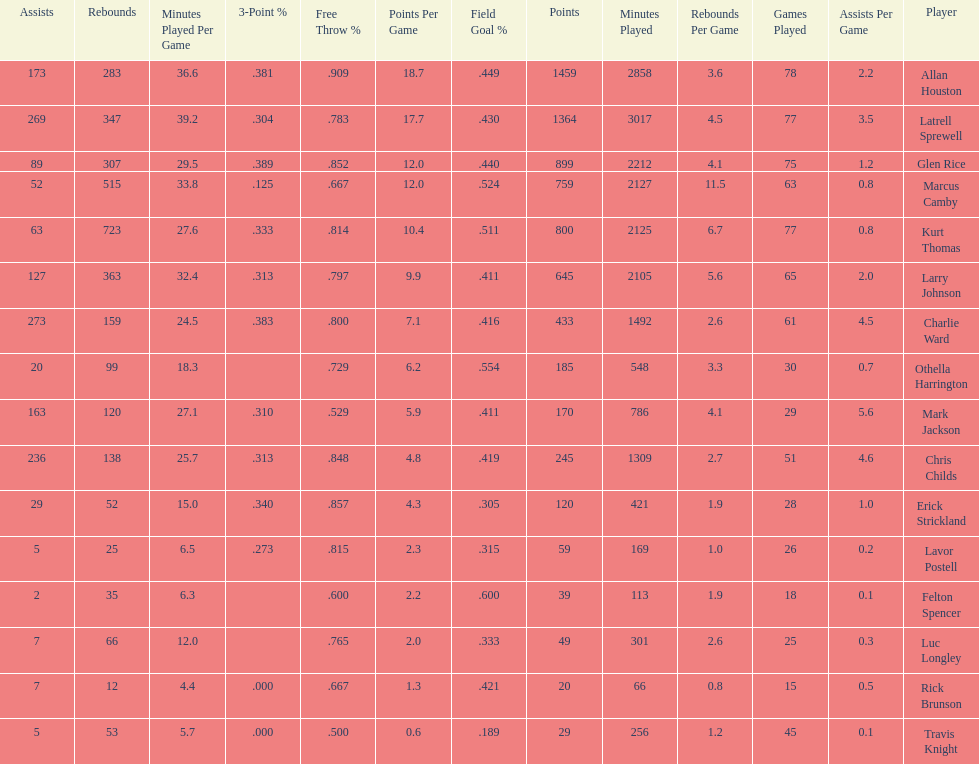Who scored more points, larry johnson or charlie ward? Larry Johnson. 